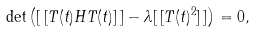Convert formula to latex. <formula><loc_0><loc_0><loc_500><loc_500>\det \left ( [ \, [ T ( t ) H T ( t ) ] \, ] - \lambda [ \, [ T ( t ) ^ { 2 } ] \, ] \right ) = 0 ,</formula> 